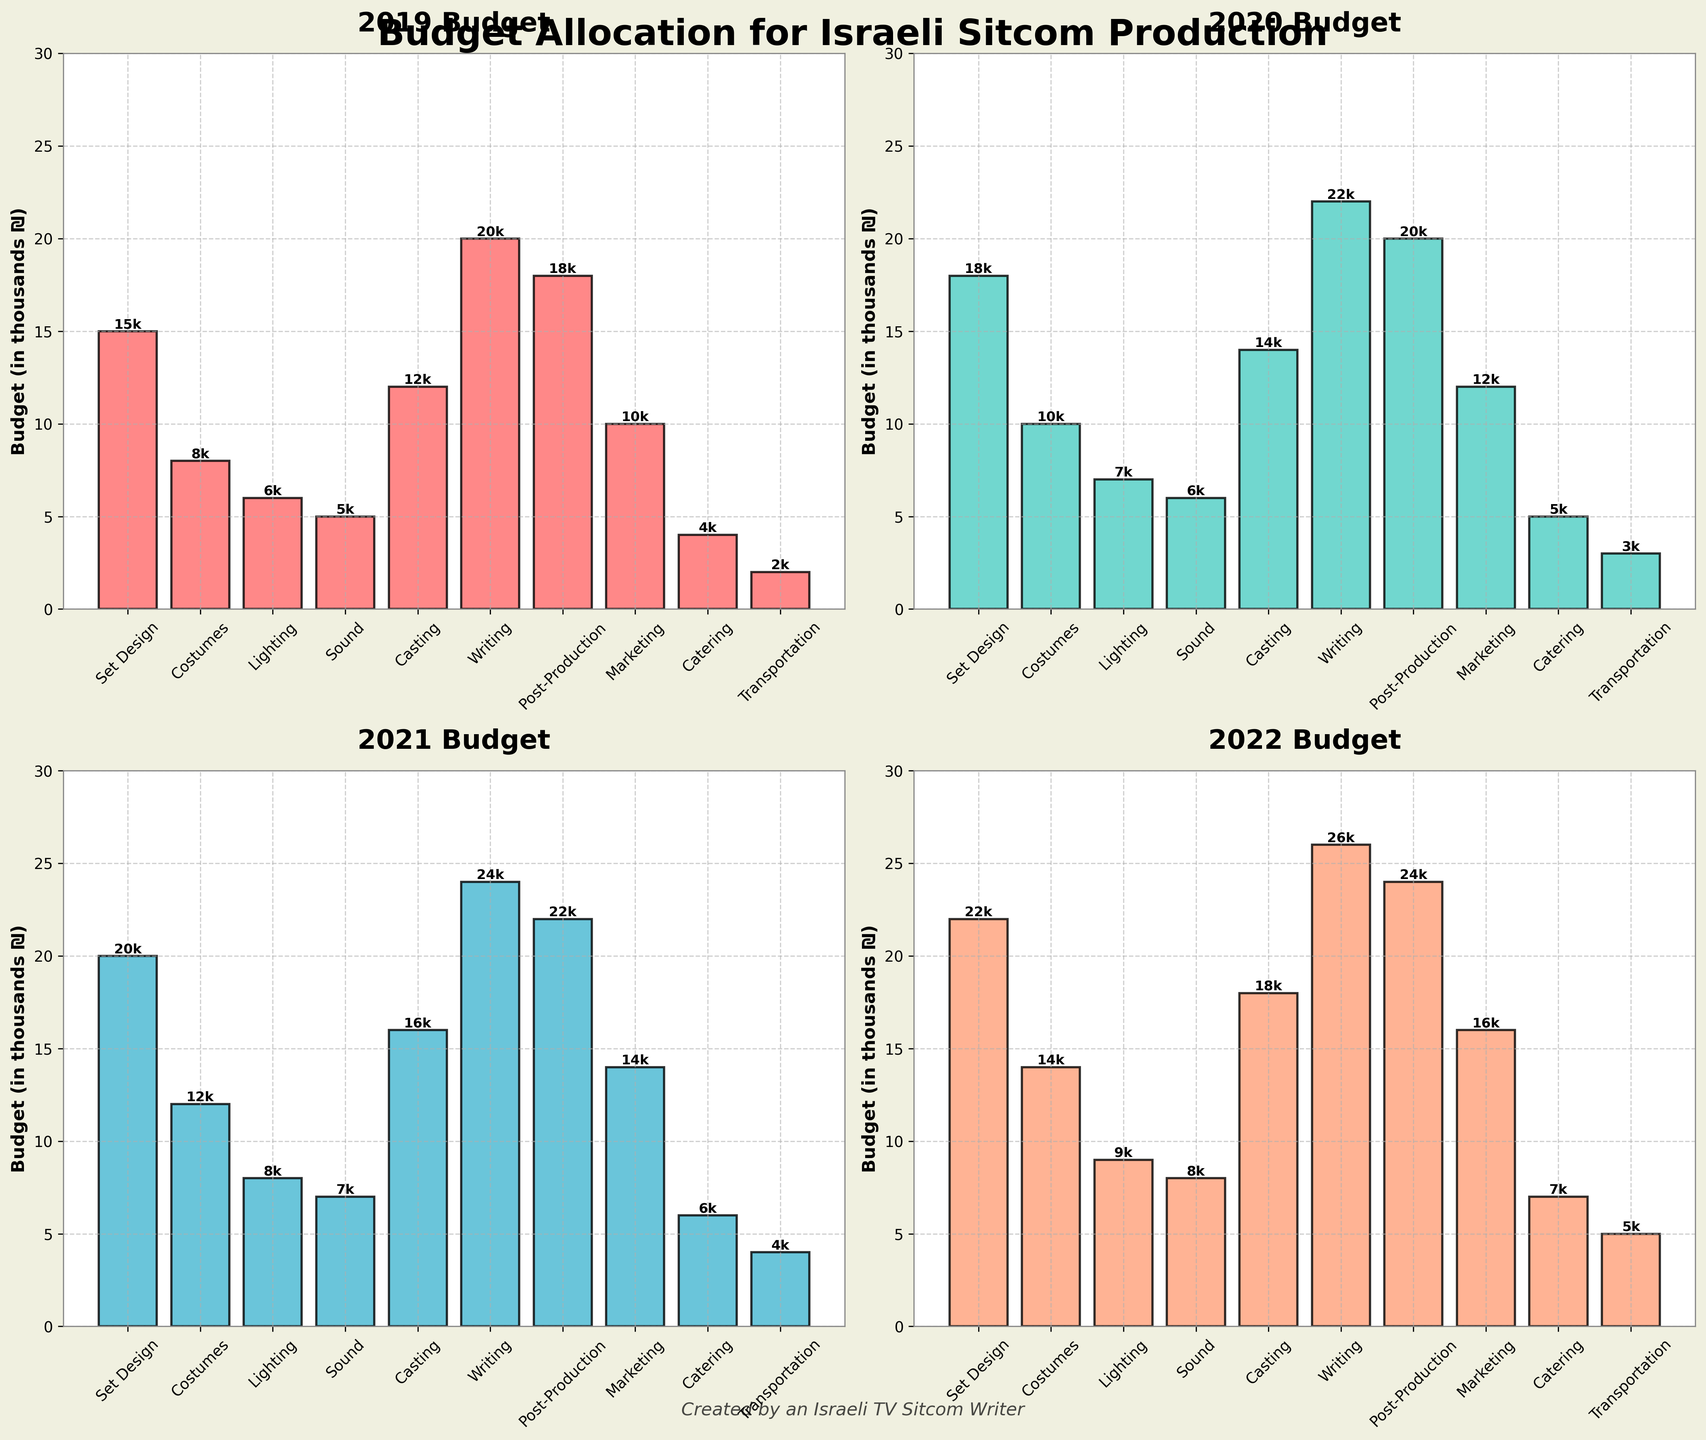How did the budget for Writing change from 2019 to 2022? In 2019, the budget for Writing was 20k. By 2022, it increased to 26k. The change is calculated as 26k - 20k = 6k.
Answer: Increased by 6k Which production aspect had the highest budget in 2019 and what was the value? In 2019, Writing had the highest budget with a value of 20k.
Answer: Writing, 20k Between 2020 and 2021, which production aspect saw the greatest budget increase and by how much? To find the greatest budget increase, we need to compare the budget for each aspect from 2020 to 2021. The values are: 
- Set Design: 18k to 20k (increase of 2k)
- Costumes: 10k to 12k (increase of 2k)
- Lighting: 7k to 8k (increase of 1k)
- Sound: 6k to 7k (increase of 1k)
- Casting: 14k to 16k (increase of 2k)
- Writing: 22k to 24k (increase of 2k)
- Post-Production: 20k to 22k (increase of 2k)
- Marketing: 12k to 14k (increase of 2k)
- Catering: 5k to 6k (increase of 1k)
- Transportation: 3k to 4k (increase of 1k)
Since several aspects saw an increase of 2k, pick any one of those (all of them are correct). E.g., Writing.
Answer: Writing, 2k What was the total budget allocation across all production aspects in 2022? Adding up all the budget values for each production aspect in 2022: 
22k (Set Design) + 14k (Costumes) + 9k (Lighting) + 8k (Sound) + 18k (Casting) + 26k (Writing) + 24k (Post-Production) + 16k (Marketing) + 7k (Catering) + 5k (Transportation) = 149k.
Answer: 149k What is their total budget allocation for Catering from 2019 to 2022? Adding up all the annual budget values for Catering:
4k (2019) + 5k (2020) + 6k (2021) + 7k (2022) = 22k.
Answer: 22k Which production aspect increased their budget continuously from 2019 to 2022? The plot shows that several production aspects increased their budget continuously from 2019 to 2022: Set Design, Costumes, Lighting, Sound, Casting, Writing, Post-Production, Marketing, Catering, and Transportation. To list one, Writing increased every year.
Answer: Writing In which year was there no increase in the budget compared to the previous year for Lighting? By checking the budgets year by year for Lighting:
- 2019 to 2020: 6k to 7k (increased)
- 2020 to 2021: 7k to 8k (increased)
- 2021 to 2022: 8k to 9k (increased)
There was an increase every year, so there is no year with no increase.
Answer: No such year In which year was Marketing's budget closest to 15k? Looking at the budget values for Marketing:
- 2019: 10k
- 2020: 12k
- 2021: 14k
- 2022: 16k
The closest value to 15k is in 2022, with 16k.
Answer: 2022 How does the budget for Post-Production in 2020 compare to that for Set Design in 2021? Budget for Post-Production in 2020 is 20k. Budget for Set Design in 2021 is 20k. Since both are the same, no comparison required.
Answer: Same 